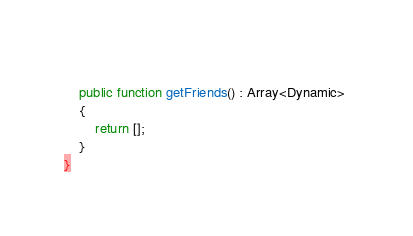<code> <loc_0><loc_0><loc_500><loc_500><_Haxe_>	
	public function getFriends() : Array<Dynamic> 
	{
		return [];
	}
}</code> 